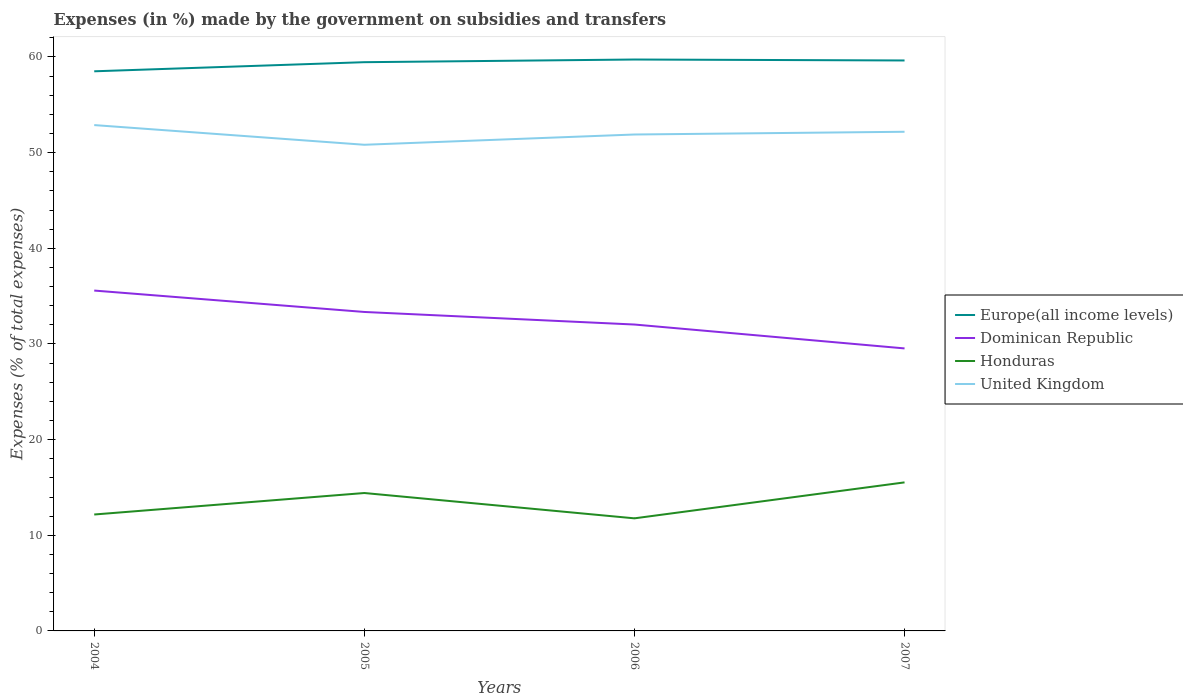How many different coloured lines are there?
Offer a very short reply. 4. Does the line corresponding to Dominican Republic intersect with the line corresponding to Honduras?
Provide a short and direct response. No. Is the number of lines equal to the number of legend labels?
Provide a short and direct response. Yes. Across all years, what is the maximum percentage of expenses made by the government on subsidies and transfers in Honduras?
Give a very brief answer. 11.77. In which year was the percentage of expenses made by the government on subsidies and transfers in Europe(all income levels) maximum?
Keep it short and to the point. 2004. What is the total percentage of expenses made by the government on subsidies and transfers in Dominican Republic in the graph?
Your answer should be very brief. 2.24. What is the difference between the highest and the second highest percentage of expenses made by the government on subsidies and transfers in United Kingdom?
Keep it short and to the point. 2.06. What is the difference between the highest and the lowest percentage of expenses made by the government on subsidies and transfers in United Kingdom?
Your answer should be very brief. 2. How many lines are there?
Your response must be concise. 4. How many years are there in the graph?
Provide a short and direct response. 4. What is the difference between two consecutive major ticks on the Y-axis?
Ensure brevity in your answer.  10. How many legend labels are there?
Make the answer very short. 4. What is the title of the graph?
Give a very brief answer. Expenses (in %) made by the government on subsidies and transfers. Does "El Salvador" appear as one of the legend labels in the graph?
Your answer should be compact. No. What is the label or title of the X-axis?
Your answer should be very brief. Years. What is the label or title of the Y-axis?
Offer a very short reply. Expenses (% of total expenses). What is the Expenses (% of total expenses) of Europe(all income levels) in 2004?
Ensure brevity in your answer.  58.5. What is the Expenses (% of total expenses) in Dominican Republic in 2004?
Your answer should be very brief. 35.58. What is the Expenses (% of total expenses) of Honduras in 2004?
Give a very brief answer. 12.17. What is the Expenses (% of total expenses) of United Kingdom in 2004?
Your response must be concise. 52.88. What is the Expenses (% of total expenses) of Europe(all income levels) in 2005?
Provide a short and direct response. 59.46. What is the Expenses (% of total expenses) in Dominican Republic in 2005?
Make the answer very short. 33.34. What is the Expenses (% of total expenses) in Honduras in 2005?
Give a very brief answer. 14.42. What is the Expenses (% of total expenses) of United Kingdom in 2005?
Give a very brief answer. 50.82. What is the Expenses (% of total expenses) in Europe(all income levels) in 2006?
Your answer should be very brief. 59.74. What is the Expenses (% of total expenses) in Dominican Republic in 2006?
Provide a succinct answer. 32.03. What is the Expenses (% of total expenses) in Honduras in 2006?
Keep it short and to the point. 11.77. What is the Expenses (% of total expenses) of United Kingdom in 2006?
Ensure brevity in your answer.  51.9. What is the Expenses (% of total expenses) in Europe(all income levels) in 2007?
Your answer should be very brief. 59.64. What is the Expenses (% of total expenses) in Dominican Republic in 2007?
Offer a terse response. 29.53. What is the Expenses (% of total expenses) in Honduras in 2007?
Your answer should be very brief. 15.53. What is the Expenses (% of total expenses) of United Kingdom in 2007?
Give a very brief answer. 52.18. Across all years, what is the maximum Expenses (% of total expenses) in Europe(all income levels)?
Give a very brief answer. 59.74. Across all years, what is the maximum Expenses (% of total expenses) of Dominican Republic?
Provide a succinct answer. 35.58. Across all years, what is the maximum Expenses (% of total expenses) of Honduras?
Keep it short and to the point. 15.53. Across all years, what is the maximum Expenses (% of total expenses) of United Kingdom?
Your answer should be compact. 52.88. Across all years, what is the minimum Expenses (% of total expenses) of Europe(all income levels)?
Your answer should be very brief. 58.5. Across all years, what is the minimum Expenses (% of total expenses) of Dominican Republic?
Your answer should be compact. 29.53. Across all years, what is the minimum Expenses (% of total expenses) in Honduras?
Offer a terse response. 11.77. Across all years, what is the minimum Expenses (% of total expenses) of United Kingdom?
Make the answer very short. 50.82. What is the total Expenses (% of total expenses) of Europe(all income levels) in the graph?
Ensure brevity in your answer.  237.34. What is the total Expenses (% of total expenses) of Dominican Republic in the graph?
Provide a succinct answer. 130.49. What is the total Expenses (% of total expenses) in Honduras in the graph?
Provide a succinct answer. 53.89. What is the total Expenses (% of total expenses) in United Kingdom in the graph?
Your response must be concise. 207.79. What is the difference between the Expenses (% of total expenses) of Europe(all income levels) in 2004 and that in 2005?
Offer a terse response. -0.95. What is the difference between the Expenses (% of total expenses) in Dominican Republic in 2004 and that in 2005?
Give a very brief answer. 2.24. What is the difference between the Expenses (% of total expenses) of Honduras in 2004 and that in 2005?
Keep it short and to the point. -2.25. What is the difference between the Expenses (% of total expenses) in United Kingdom in 2004 and that in 2005?
Your answer should be very brief. 2.06. What is the difference between the Expenses (% of total expenses) in Europe(all income levels) in 2004 and that in 2006?
Provide a short and direct response. -1.23. What is the difference between the Expenses (% of total expenses) in Dominican Republic in 2004 and that in 2006?
Make the answer very short. 3.55. What is the difference between the Expenses (% of total expenses) in Honduras in 2004 and that in 2006?
Keep it short and to the point. 0.4. What is the difference between the Expenses (% of total expenses) in United Kingdom in 2004 and that in 2006?
Your answer should be compact. 0.98. What is the difference between the Expenses (% of total expenses) of Europe(all income levels) in 2004 and that in 2007?
Keep it short and to the point. -1.13. What is the difference between the Expenses (% of total expenses) of Dominican Republic in 2004 and that in 2007?
Give a very brief answer. 6.05. What is the difference between the Expenses (% of total expenses) in Honduras in 2004 and that in 2007?
Provide a short and direct response. -3.36. What is the difference between the Expenses (% of total expenses) in United Kingdom in 2004 and that in 2007?
Your response must be concise. 0.7. What is the difference between the Expenses (% of total expenses) in Europe(all income levels) in 2005 and that in 2006?
Give a very brief answer. -0.28. What is the difference between the Expenses (% of total expenses) of Dominican Republic in 2005 and that in 2006?
Offer a very short reply. 1.31. What is the difference between the Expenses (% of total expenses) in Honduras in 2005 and that in 2006?
Provide a succinct answer. 2.65. What is the difference between the Expenses (% of total expenses) in United Kingdom in 2005 and that in 2006?
Your response must be concise. -1.07. What is the difference between the Expenses (% of total expenses) in Europe(all income levels) in 2005 and that in 2007?
Offer a very short reply. -0.18. What is the difference between the Expenses (% of total expenses) of Dominican Republic in 2005 and that in 2007?
Provide a succinct answer. 3.81. What is the difference between the Expenses (% of total expenses) of Honduras in 2005 and that in 2007?
Offer a very short reply. -1.11. What is the difference between the Expenses (% of total expenses) of United Kingdom in 2005 and that in 2007?
Give a very brief answer. -1.36. What is the difference between the Expenses (% of total expenses) of Europe(all income levels) in 2006 and that in 2007?
Provide a short and direct response. 0.1. What is the difference between the Expenses (% of total expenses) of Dominican Republic in 2006 and that in 2007?
Provide a short and direct response. 2.5. What is the difference between the Expenses (% of total expenses) in Honduras in 2006 and that in 2007?
Your answer should be compact. -3.76. What is the difference between the Expenses (% of total expenses) of United Kingdom in 2006 and that in 2007?
Give a very brief answer. -0.29. What is the difference between the Expenses (% of total expenses) of Europe(all income levels) in 2004 and the Expenses (% of total expenses) of Dominican Republic in 2005?
Your answer should be compact. 25.16. What is the difference between the Expenses (% of total expenses) in Europe(all income levels) in 2004 and the Expenses (% of total expenses) in Honduras in 2005?
Provide a short and direct response. 44.09. What is the difference between the Expenses (% of total expenses) of Europe(all income levels) in 2004 and the Expenses (% of total expenses) of United Kingdom in 2005?
Your response must be concise. 7.68. What is the difference between the Expenses (% of total expenses) in Dominican Republic in 2004 and the Expenses (% of total expenses) in Honduras in 2005?
Ensure brevity in your answer.  21.17. What is the difference between the Expenses (% of total expenses) in Dominican Republic in 2004 and the Expenses (% of total expenses) in United Kingdom in 2005?
Provide a succinct answer. -15.24. What is the difference between the Expenses (% of total expenses) of Honduras in 2004 and the Expenses (% of total expenses) of United Kingdom in 2005?
Your response must be concise. -38.65. What is the difference between the Expenses (% of total expenses) in Europe(all income levels) in 2004 and the Expenses (% of total expenses) in Dominican Republic in 2006?
Provide a short and direct response. 26.47. What is the difference between the Expenses (% of total expenses) of Europe(all income levels) in 2004 and the Expenses (% of total expenses) of Honduras in 2006?
Provide a short and direct response. 46.73. What is the difference between the Expenses (% of total expenses) of Europe(all income levels) in 2004 and the Expenses (% of total expenses) of United Kingdom in 2006?
Your answer should be compact. 6.61. What is the difference between the Expenses (% of total expenses) of Dominican Republic in 2004 and the Expenses (% of total expenses) of Honduras in 2006?
Provide a short and direct response. 23.81. What is the difference between the Expenses (% of total expenses) in Dominican Republic in 2004 and the Expenses (% of total expenses) in United Kingdom in 2006?
Ensure brevity in your answer.  -16.32. What is the difference between the Expenses (% of total expenses) of Honduras in 2004 and the Expenses (% of total expenses) of United Kingdom in 2006?
Ensure brevity in your answer.  -39.73. What is the difference between the Expenses (% of total expenses) in Europe(all income levels) in 2004 and the Expenses (% of total expenses) in Dominican Republic in 2007?
Offer a terse response. 28.97. What is the difference between the Expenses (% of total expenses) in Europe(all income levels) in 2004 and the Expenses (% of total expenses) in Honduras in 2007?
Your answer should be very brief. 42.98. What is the difference between the Expenses (% of total expenses) of Europe(all income levels) in 2004 and the Expenses (% of total expenses) of United Kingdom in 2007?
Your answer should be very brief. 6.32. What is the difference between the Expenses (% of total expenses) in Dominican Republic in 2004 and the Expenses (% of total expenses) in Honduras in 2007?
Your answer should be compact. 20.05. What is the difference between the Expenses (% of total expenses) in Dominican Republic in 2004 and the Expenses (% of total expenses) in United Kingdom in 2007?
Your answer should be very brief. -16.6. What is the difference between the Expenses (% of total expenses) in Honduras in 2004 and the Expenses (% of total expenses) in United Kingdom in 2007?
Ensure brevity in your answer.  -40.01. What is the difference between the Expenses (% of total expenses) in Europe(all income levels) in 2005 and the Expenses (% of total expenses) in Dominican Republic in 2006?
Make the answer very short. 27.43. What is the difference between the Expenses (% of total expenses) of Europe(all income levels) in 2005 and the Expenses (% of total expenses) of Honduras in 2006?
Keep it short and to the point. 47.69. What is the difference between the Expenses (% of total expenses) of Europe(all income levels) in 2005 and the Expenses (% of total expenses) of United Kingdom in 2006?
Your answer should be very brief. 7.56. What is the difference between the Expenses (% of total expenses) in Dominican Republic in 2005 and the Expenses (% of total expenses) in Honduras in 2006?
Provide a short and direct response. 21.57. What is the difference between the Expenses (% of total expenses) in Dominican Republic in 2005 and the Expenses (% of total expenses) in United Kingdom in 2006?
Your answer should be very brief. -18.55. What is the difference between the Expenses (% of total expenses) in Honduras in 2005 and the Expenses (% of total expenses) in United Kingdom in 2006?
Provide a succinct answer. -37.48. What is the difference between the Expenses (% of total expenses) in Europe(all income levels) in 2005 and the Expenses (% of total expenses) in Dominican Republic in 2007?
Your response must be concise. 29.92. What is the difference between the Expenses (% of total expenses) in Europe(all income levels) in 2005 and the Expenses (% of total expenses) in Honduras in 2007?
Make the answer very short. 43.93. What is the difference between the Expenses (% of total expenses) in Europe(all income levels) in 2005 and the Expenses (% of total expenses) in United Kingdom in 2007?
Provide a succinct answer. 7.27. What is the difference between the Expenses (% of total expenses) in Dominican Republic in 2005 and the Expenses (% of total expenses) in Honduras in 2007?
Make the answer very short. 17.82. What is the difference between the Expenses (% of total expenses) in Dominican Republic in 2005 and the Expenses (% of total expenses) in United Kingdom in 2007?
Offer a terse response. -18.84. What is the difference between the Expenses (% of total expenses) in Honduras in 2005 and the Expenses (% of total expenses) in United Kingdom in 2007?
Offer a very short reply. -37.77. What is the difference between the Expenses (% of total expenses) of Europe(all income levels) in 2006 and the Expenses (% of total expenses) of Dominican Republic in 2007?
Ensure brevity in your answer.  30.2. What is the difference between the Expenses (% of total expenses) in Europe(all income levels) in 2006 and the Expenses (% of total expenses) in Honduras in 2007?
Ensure brevity in your answer.  44.21. What is the difference between the Expenses (% of total expenses) of Europe(all income levels) in 2006 and the Expenses (% of total expenses) of United Kingdom in 2007?
Your answer should be compact. 7.55. What is the difference between the Expenses (% of total expenses) in Dominican Republic in 2006 and the Expenses (% of total expenses) in Honduras in 2007?
Keep it short and to the point. 16.5. What is the difference between the Expenses (% of total expenses) in Dominican Republic in 2006 and the Expenses (% of total expenses) in United Kingdom in 2007?
Give a very brief answer. -20.15. What is the difference between the Expenses (% of total expenses) in Honduras in 2006 and the Expenses (% of total expenses) in United Kingdom in 2007?
Keep it short and to the point. -40.41. What is the average Expenses (% of total expenses) of Europe(all income levels) per year?
Make the answer very short. 59.33. What is the average Expenses (% of total expenses) of Dominican Republic per year?
Give a very brief answer. 32.62. What is the average Expenses (% of total expenses) in Honduras per year?
Offer a terse response. 13.47. What is the average Expenses (% of total expenses) in United Kingdom per year?
Provide a succinct answer. 51.95. In the year 2004, what is the difference between the Expenses (% of total expenses) of Europe(all income levels) and Expenses (% of total expenses) of Dominican Republic?
Provide a short and direct response. 22.92. In the year 2004, what is the difference between the Expenses (% of total expenses) of Europe(all income levels) and Expenses (% of total expenses) of Honduras?
Your answer should be compact. 46.33. In the year 2004, what is the difference between the Expenses (% of total expenses) in Europe(all income levels) and Expenses (% of total expenses) in United Kingdom?
Your response must be concise. 5.62. In the year 2004, what is the difference between the Expenses (% of total expenses) of Dominican Republic and Expenses (% of total expenses) of Honduras?
Your answer should be very brief. 23.41. In the year 2004, what is the difference between the Expenses (% of total expenses) in Dominican Republic and Expenses (% of total expenses) in United Kingdom?
Provide a succinct answer. -17.3. In the year 2004, what is the difference between the Expenses (% of total expenses) in Honduras and Expenses (% of total expenses) in United Kingdom?
Your answer should be compact. -40.71. In the year 2005, what is the difference between the Expenses (% of total expenses) in Europe(all income levels) and Expenses (% of total expenses) in Dominican Republic?
Keep it short and to the point. 26.11. In the year 2005, what is the difference between the Expenses (% of total expenses) of Europe(all income levels) and Expenses (% of total expenses) of Honduras?
Give a very brief answer. 45.04. In the year 2005, what is the difference between the Expenses (% of total expenses) in Europe(all income levels) and Expenses (% of total expenses) in United Kingdom?
Offer a very short reply. 8.63. In the year 2005, what is the difference between the Expenses (% of total expenses) of Dominican Republic and Expenses (% of total expenses) of Honduras?
Your response must be concise. 18.93. In the year 2005, what is the difference between the Expenses (% of total expenses) of Dominican Republic and Expenses (% of total expenses) of United Kingdom?
Offer a very short reply. -17.48. In the year 2005, what is the difference between the Expenses (% of total expenses) in Honduras and Expenses (% of total expenses) in United Kingdom?
Give a very brief answer. -36.41. In the year 2006, what is the difference between the Expenses (% of total expenses) in Europe(all income levels) and Expenses (% of total expenses) in Dominican Republic?
Provide a short and direct response. 27.7. In the year 2006, what is the difference between the Expenses (% of total expenses) in Europe(all income levels) and Expenses (% of total expenses) in Honduras?
Keep it short and to the point. 47.97. In the year 2006, what is the difference between the Expenses (% of total expenses) in Europe(all income levels) and Expenses (% of total expenses) in United Kingdom?
Offer a terse response. 7.84. In the year 2006, what is the difference between the Expenses (% of total expenses) of Dominican Republic and Expenses (% of total expenses) of Honduras?
Offer a very short reply. 20.26. In the year 2006, what is the difference between the Expenses (% of total expenses) of Dominican Republic and Expenses (% of total expenses) of United Kingdom?
Your response must be concise. -19.87. In the year 2006, what is the difference between the Expenses (% of total expenses) in Honduras and Expenses (% of total expenses) in United Kingdom?
Offer a terse response. -40.13. In the year 2007, what is the difference between the Expenses (% of total expenses) in Europe(all income levels) and Expenses (% of total expenses) in Dominican Republic?
Ensure brevity in your answer.  30.1. In the year 2007, what is the difference between the Expenses (% of total expenses) of Europe(all income levels) and Expenses (% of total expenses) of Honduras?
Keep it short and to the point. 44.11. In the year 2007, what is the difference between the Expenses (% of total expenses) in Europe(all income levels) and Expenses (% of total expenses) in United Kingdom?
Provide a succinct answer. 7.45. In the year 2007, what is the difference between the Expenses (% of total expenses) in Dominican Republic and Expenses (% of total expenses) in Honduras?
Give a very brief answer. 14.01. In the year 2007, what is the difference between the Expenses (% of total expenses) in Dominican Republic and Expenses (% of total expenses) in United Kingdom?
Ensure brevity in your answer.  -22.65. In the year 2007, what is the difference between the Expenses (% of total expenses) of Honduras and Expenses (% of total expenses) of United Kingdom?
Ensure brevity in your answer.  -36.65. What is the ratio of the Expenses (% of total expenses) of Dominican Republic in 2004 to that in 2005?
Offer a very short reply. 1.07. What is the ratio of the Expenses (% of total expenses) in Honduras in 2004 to that in 2005?
Your answer should be compact. 0.84. What is the ratio of the Expenses (% of total expenses) of United Kingdom in 2004 to that in 2005?
Offer a terse response. 1.04. What is the ratio of the Expenses (% of total expenses) in Europe(all income levels) in 2004 to that in 2006?
Offer a very short reply. 0.98. What is the ratio of the Expenses (% of total expenses) of Dominican Republic in 2004 to that in 2006?
Keep it short and to the point. 1.11. What is the ratio of the Expenses (% of total expenses) of Honduras in 2004 to that in 2006?
Your response must be concise. 1.03. What is the ratio of the Expenses (% of total expenses) in Europe(all income levels) in 2004 to that in 2007?
Your answer should be compact. 0.98. What is the ratio of the Expenses (% of total expenses) of Dominican Republic in 2004 to that in 2007?
Ensure brevity in your answer.  1.2. What is the ratio of the Expenses (% of total expenses) of Honduras in 2004 to that in 2007?
Make the answer very short. 0.78. What is the ratio of the Expenses (% of total expenses) of United Kingdom in 2004 to that in 2007?
Provide a short and direct response. 1.01. What is the ratio of the Expenses (% of total expenses) of Europe(all income levels) in 2005 to that in 2006?
Provide a succinct answer. 1. What is the ratio of the Expenses (% of total expenses) of Dominican Republic in 2005 to that in 2006?
Your response must be concise. 1.04. What is the ratio of the Expenses (% of total expenses) of Honduras in 2005 to that in 2006?
Make the answer very short. 1.22. What is the ratio of the Expenses (% of total expenses) of United Kingdom in 2005 to that in 2006?
Give a very brief answer. 0.98. What is the ratio of the Expenses (% of total expenses) of Europe(all income levels) in 2005 to that in 2007?
Provide a short and direct response. 1. What is the ratio of the Expenses (% of total expenses) in Dominican Republic in 2005 to that in 2007?
Offer a very short reply. 1.13. What is the ratio of the Expenses (% of total expenses) in Honduras in 2005 to that in 2007?
Keep it short and to the point. 0.93. What is the ratio of the Expenses (% of total expenses) of Europe(all income levels) in 2006 to that in 2007?
Your answer should be compact. 1. What is the ratio of the Expenses (% of total expenses) of Dominican Republic in 2006 to that in 2007?
Offer a terse response. 1.08. What is the ratio of the Expenses (% of total expenses) of Honduras in 2006 to that in 2007?
Provide a short and direct response. 0.76. What is the difference between the highest and the second highest Expenses (% of total expenses) in Europe(all income levels)?
Ensure brevity in your answer.  0.1. What is the difference between the highest and the second highest Expenses (% of total expenses) of Dominican Republic?
Offer a very short reply. 2.24. What is the difference between the highest and the second highest Expenses (% of total expenses) of Honduras?
Ensure brevity in your answer.  1.11. What is the difference between the highest and the second highest Expenses (% of total expenses) of United Kingdom?
Provide a short and direct response. 0.7. What is the difference between the highest and the lowest Expenses (% of total expenses) in Europe(all income levels)?
Your answer should be very brief. 1.23. What is the difference between the highest and the lowest Expenses (% of total expenses) in Dominican Republic?
Offer a terse response. 6.05. What is the difference between the highest and the lowest Expenses (% of total expenses) of Honduras?
Your answer should be compact. 3.76. What is the difference between the highest and the lowest Expenses (% of total expenses) in United Kingdom?
Keep it short and to the point. 2.06. 